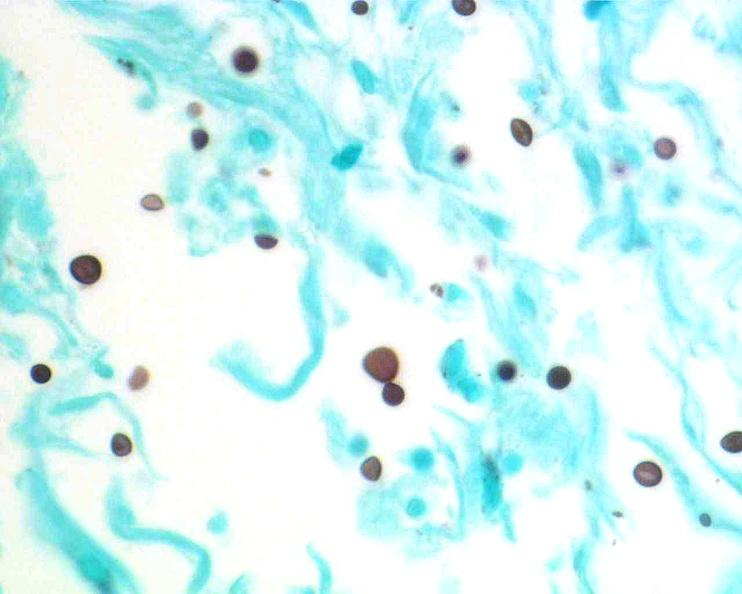does this image show brain, cryptococcal meningitis?
Answer the question using a single word or phrase. Yes 